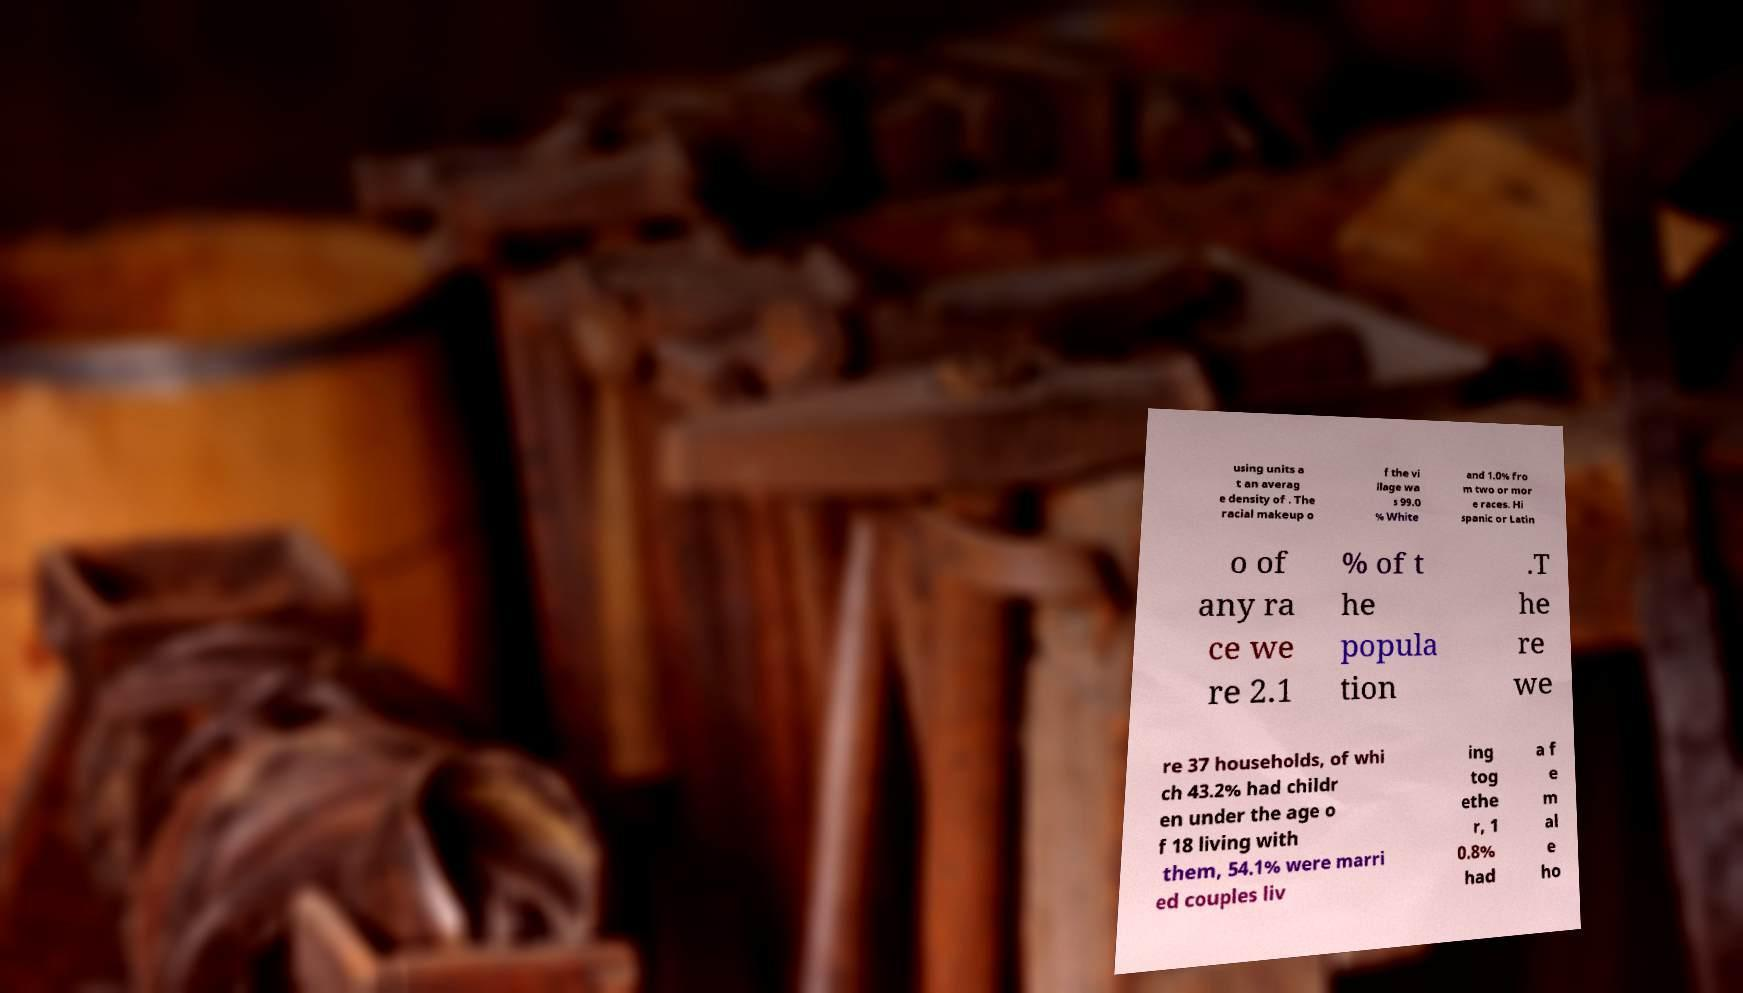Can you accurately transcribe the text from the provided image for me? using units a t an averag e density of . The racial makeup o f the vi llage wa s 99.0 % White and 1.0% fro m two or mor e races. Hi spanic or Latin o of any ra ce we re 2.1 % of t he popula tion .T he re we re 37 households, of whi ch 43.2% had childr en under the age o f 18 living with them, 54.1% were marri ed couples liv ing tog ethe r, 1 0.8% had a f e m al e ho 